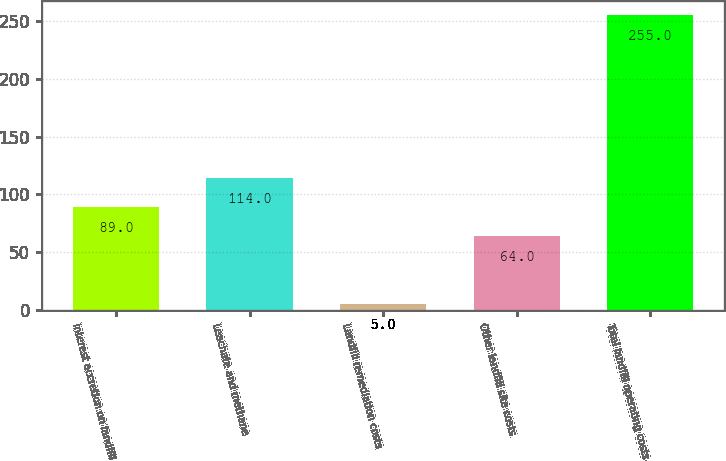<chart> <loc_0><loc_0><loc_500><loc_500><bar_chart><fcel>Interest accretion on landfill<fcel>Leachate and methane<fcel>Landfill remediation costs<fcel>Other landfill site costs<fcel>Total landfill operating costs<nl><fcel>89<fcel>114<fcel>5<fcel>64<fcel>255<nl></chart> 